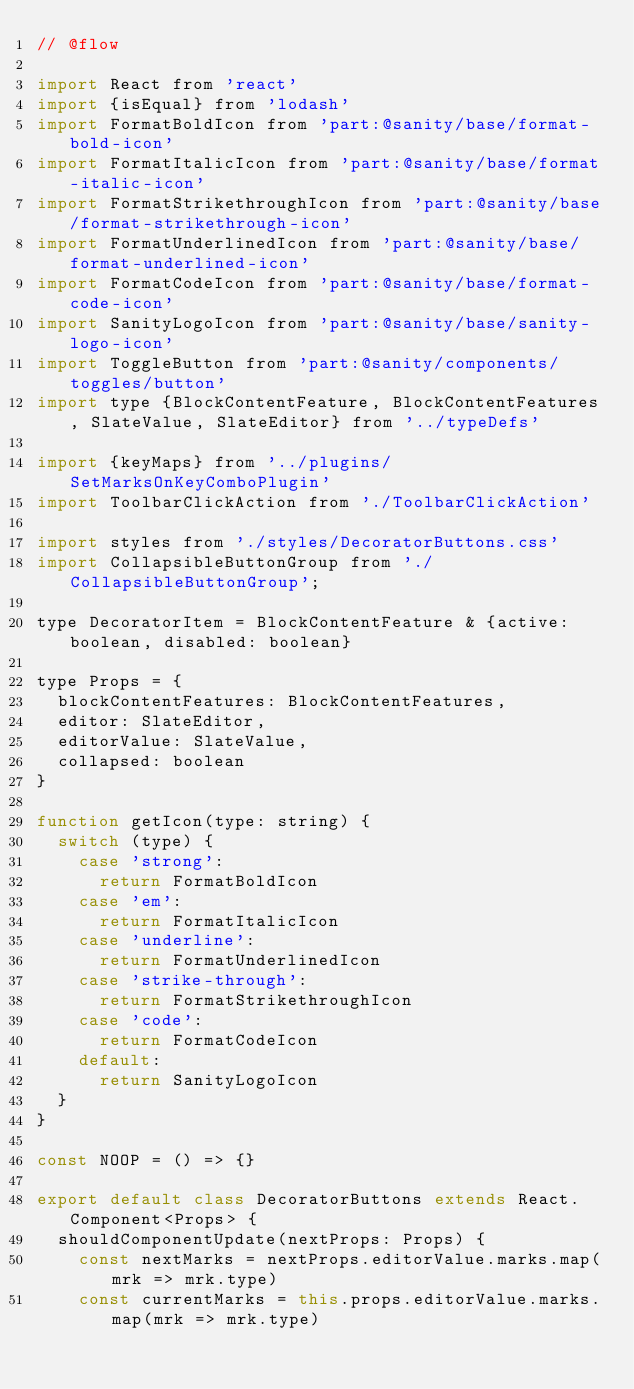<code> <loc_0><loc_0><loc_500><loc_500><_JavaScript_>// @flow

import React from 'react'
import {isEqual} from 'lodash'
import FormatBoldIcon from 'part:@sanity/base/format-bold-icon'
import FormatItalicIcon from 'part:@sanity/base/format-italic-icon'
import FormatStrikethroughIcon from 'part:@sanity/base/format-strikethrough-icon'
import FormatUnderlinedIcon from 'part:@sanity/base/format-underlined-icon'
import FormatCodeIcon from 'part:@sanity/base/format-code-icon'
import SanityLogoIcon from 'part:@sanity/base/sanity-logo-icon'
import ToggleButton from 'part:@sanity/components/toggles/button'
import type {BlockContentFeature, BlockContentFeatures, SlateValue, SlateEditor} from '../typeDefs'

import {keyMaps} from '../plugins/SetMarksOnKeyComboPlugin'
import ToolbarClickAction from './ToolbarClickAction'

import styles from './styles/DecoratorButtons.css'
import CollapsibleButtonGroup from './CollapsibleButtonGroup';

type DecoratorItem = BlockContentFeature & {active: boolean, disabled: boolean}

type Props = {
  blockContentFeatures: BlockContentFeatures,
  editor: SlateEditor,
  editorValue: SlateValue,
  collapsed: boolean
}

function getIcon(type: string) {
  switch (type) {
    case 'strong':
      return FormatBoldIcon
    case 'em':
      return FormatItalicIcon
    case 'underline':
      return FormatUnderlinedIcon
    case 'strike-through':
      return FormatStrikethroughIcon
    case 'code':
      return FormatCodeIcon
    default:
      return SanityLogoIcon
  }
}

const NOOP = () => {}

export default class DecoratorButtons extends React.Component<Props> {
  shouldComponentUpdate(nextProps: Props) {
    const nextMarks = nextProps.editorValue.marks.map(mrk => mrk.type)
    const currentMarks = this.props.editorValue.marks.map(mrk => mrk.type)</code> 